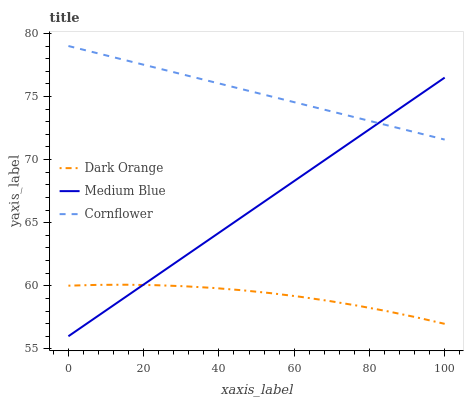Does Dark Orange have the minimum area under the curve?
Answer yes or no. Yes. Does Cornflower have the maximum area under the curve?
Answer yes or no. Yes. Does Medium Blue have the minimum area under the curve?
Answer yes or no. No. Does Medium Blue have the maximum area under the curve?
Answer yes or no. No. Is Medium Blue the smoothest?
Answer yes or no. Yes. Is Dark Orange the roughest?
Answer yes or no. Yes. Is Cornflower the smoothest?
Answer yes or no. No. Is Cornflower the roughest?
Answer yes or no. No. Does Medium Blue have the lowest value?
Answer yes or no. Yes. Does Cornflower have the lowest value?
Answer yes or no. No. Does Cornflower have the highest value?
Answer yes or no. Yes. Does Medium Blue have the highest value?
Answer yes or no. No. Is Dark Orange less than Cornflower?
Answer yes or no. Yes. Is Cornflower greater than Dark Orange?
Answer yes or no. Yes. Does Cornflower intersect Medium Blue?
Answer yes or no. Yes. Is Cornflower less than Medium Blue?
Answer yes or no. No. Is Cornflower greater than Medium Blue?
Answer yes or no. No. Does Dark Orange intersect Cornflower?
Answer yes or no. No. 